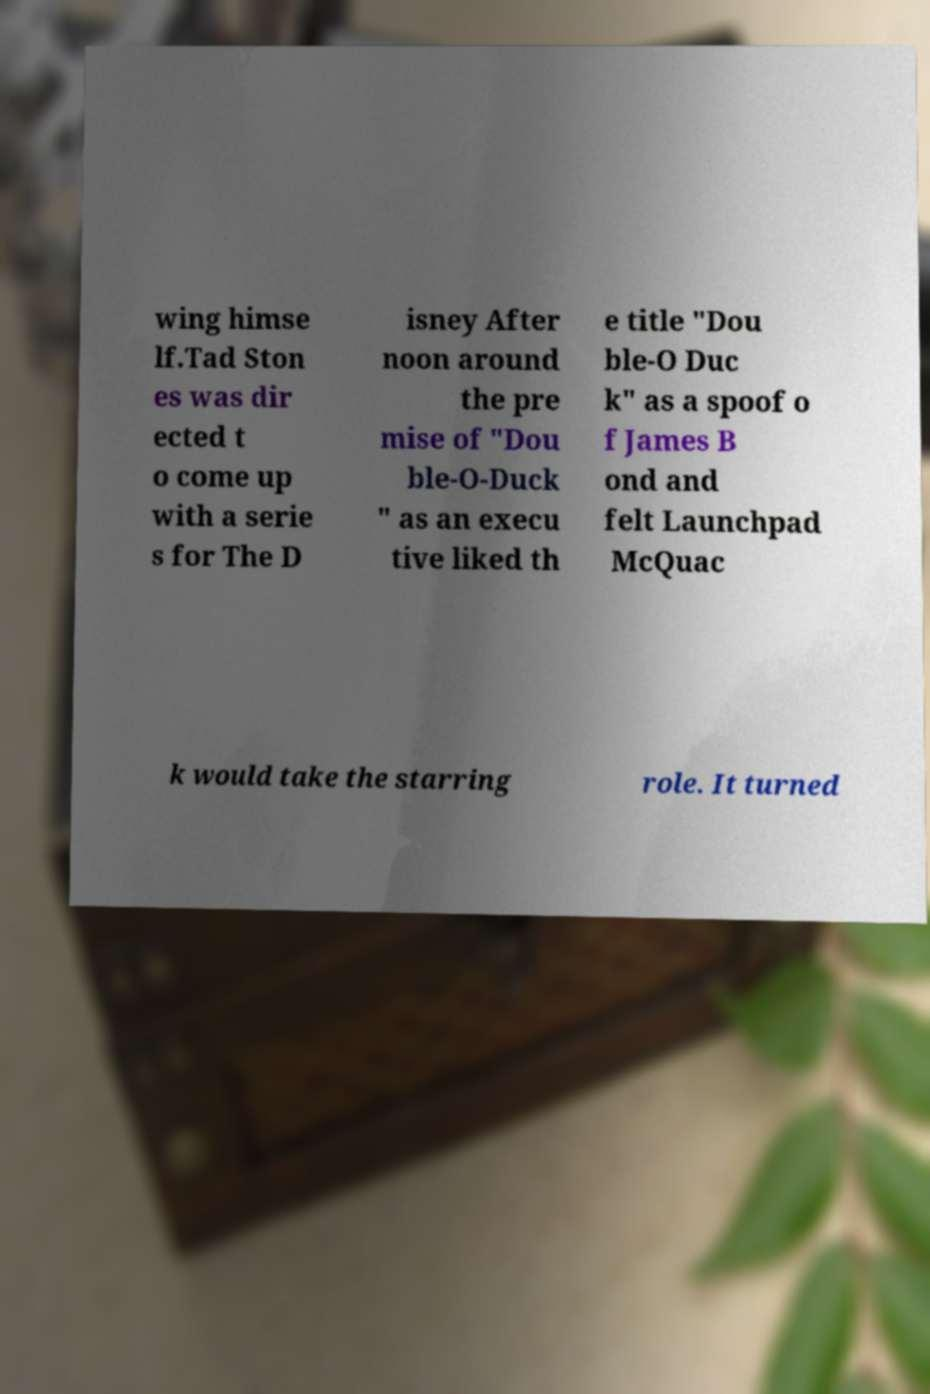Please identify and transcribe the text found in this image. wing himse lf.Tad Ston es was dir ected t o come up with a serie s for The D isney After noon around the pre mise of "Dou ble-O-Duck " as an execu tive liked th e title "Dou ble-O Duc k" as a spoof o f James B ond and felt Launchpad McQuac k would take the starring role. It turned 